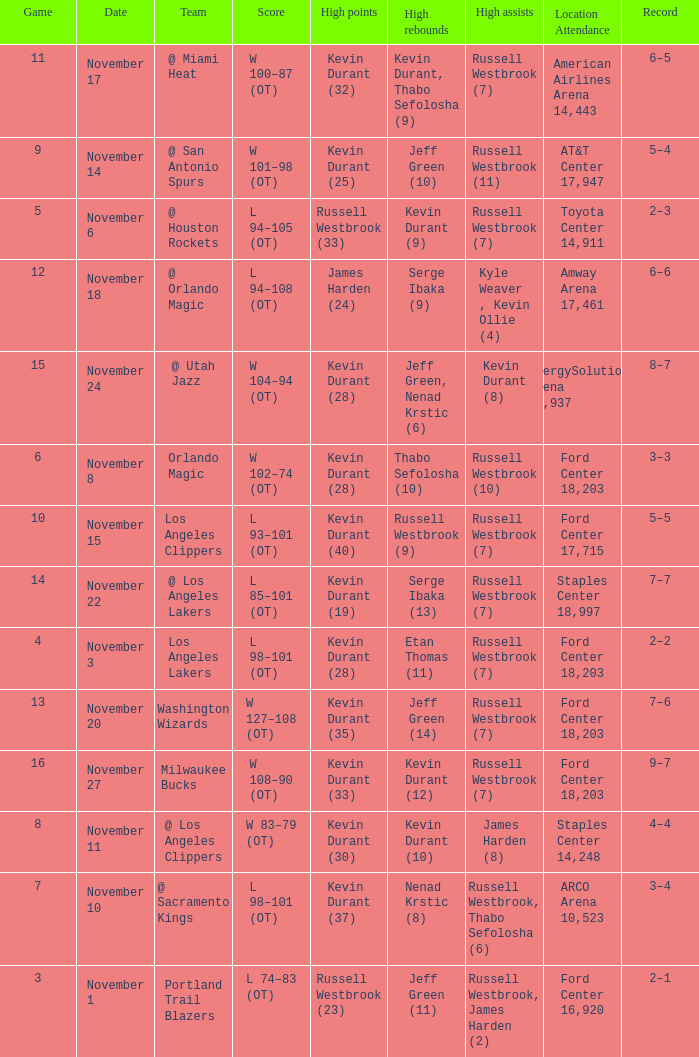Where was the game in which Kevin Durant (25) did the most high points played? AT&T Center 17,947. 